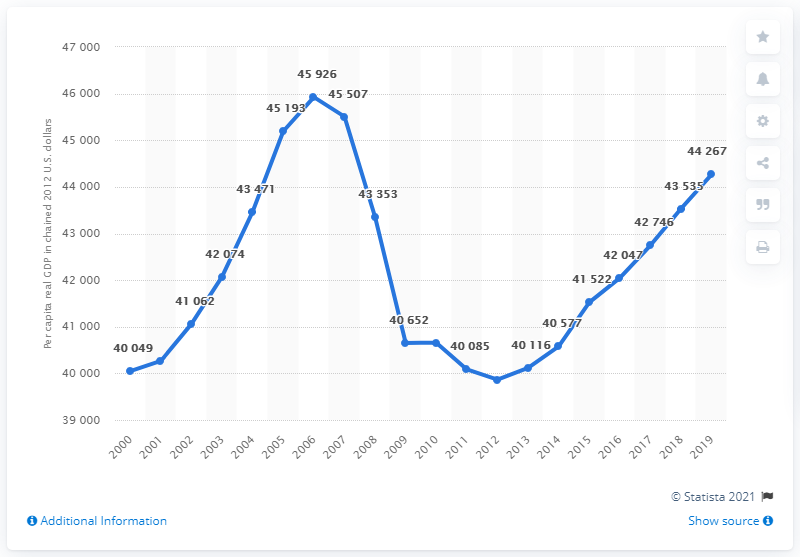Give some essential details in this illustration. In 2012, the per capita real GDP of Florida was chained. 